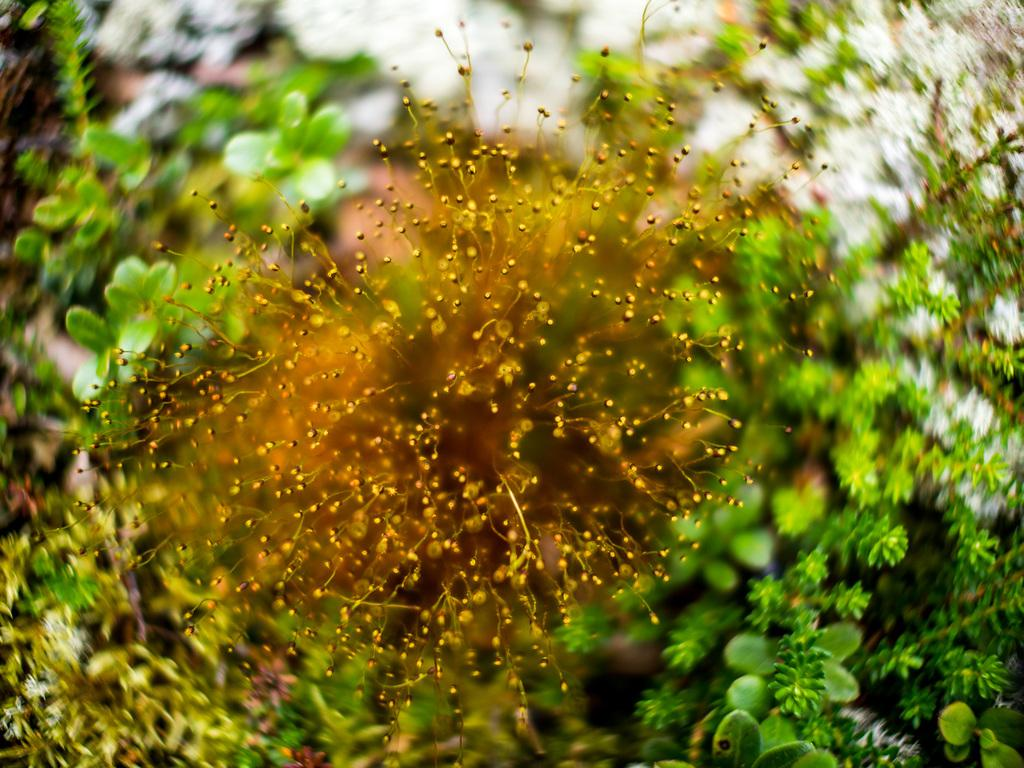What is located in the foreground of the image? There are flowers in the foreground of the image. What can be seen in the background of the image? There are leaves and plants in the background of the image. What statement does the maid make about the flowers in the image? There is no maid present in the image, and therefore no statement can be attributed to her. What type of bed can be seen in the image? There is no bed present in the image; it features flowers in the foreground and leaves and plants in the background. 